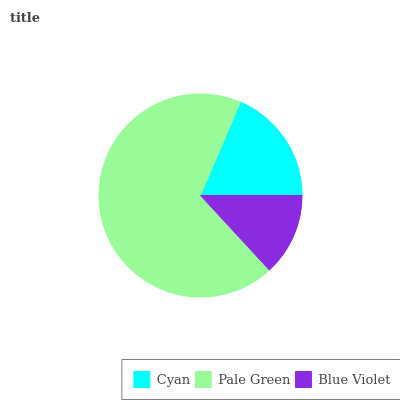Is Blue Violet the minimum?
Answer yes or no. Yes. Is Pale Green the maximum?
Answer yes or no. Yes. Is Pale Green the minimum?
Answer yes or no. No. Is Blue Violet the maximum?
Answer yes or no. No. Is Pale Green greater than Blue Violet?
Answer yes or no. Yes. Is Blue Violet less than Pale Green?
Answer yes or no. Yes. Is Blue Violet greater than Pale Green?
Answer yes or no. No. Is Pale Green less than Blue Violet?
Answer yes or no. No. Is Cyan the high median?
Answer yes or no. Yes. Is Cyan the low median?
Answer yes or no. Yes. Is Blue Violet the high median?
Answer yes or no. No. Is Pale Green the low median?
Answer yes or no. No. 